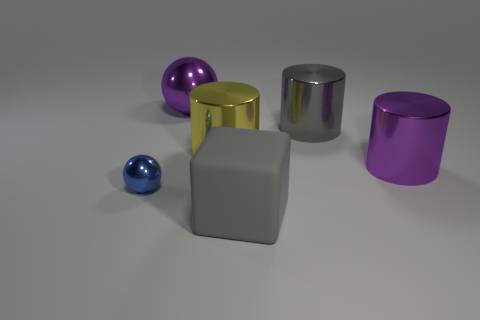Add 3 big cyan metal cylinders. How many objects exist? 9 Subtract all balls. How many objects are left? 4 Subtract all small blue shiny spheres. Subtract all big yellow shiny objects. How many objects are left? 4 Add 6 big yellow cylinders. How many big yellow cylinders are left? 7 Add 4 gray matte cubes. How many gray matte cubes exist? 5 Subtract 0 blue cubes. How many objects are left? 6 